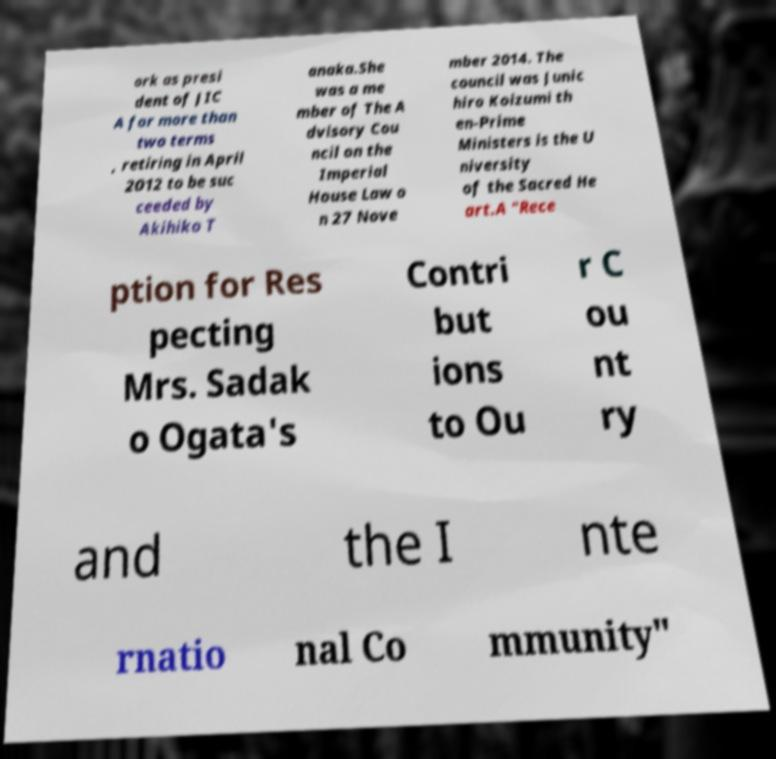Can you read and provide the text displayed in the image?This photo seems to have some interesting text. Can you extract and type it out for me? ork as presi dent of JIC A for more than two terms , retiring in April 2012 to be suc ceeded by Akihiko T anaka.She was a me mber of The A dvisory Cou ncil on the Imperial House Law o n 27 Nove mber 2014. The council was Junic hiro Koizumi th en-Prime Ministers is the U niversity of the Sacred He art.A "Rece ption for Res pecting Mrs. Sadak o Ogata's Contri but ions to Ou r C ou nt ry and the I nte rnatio nal Co mmunity" 